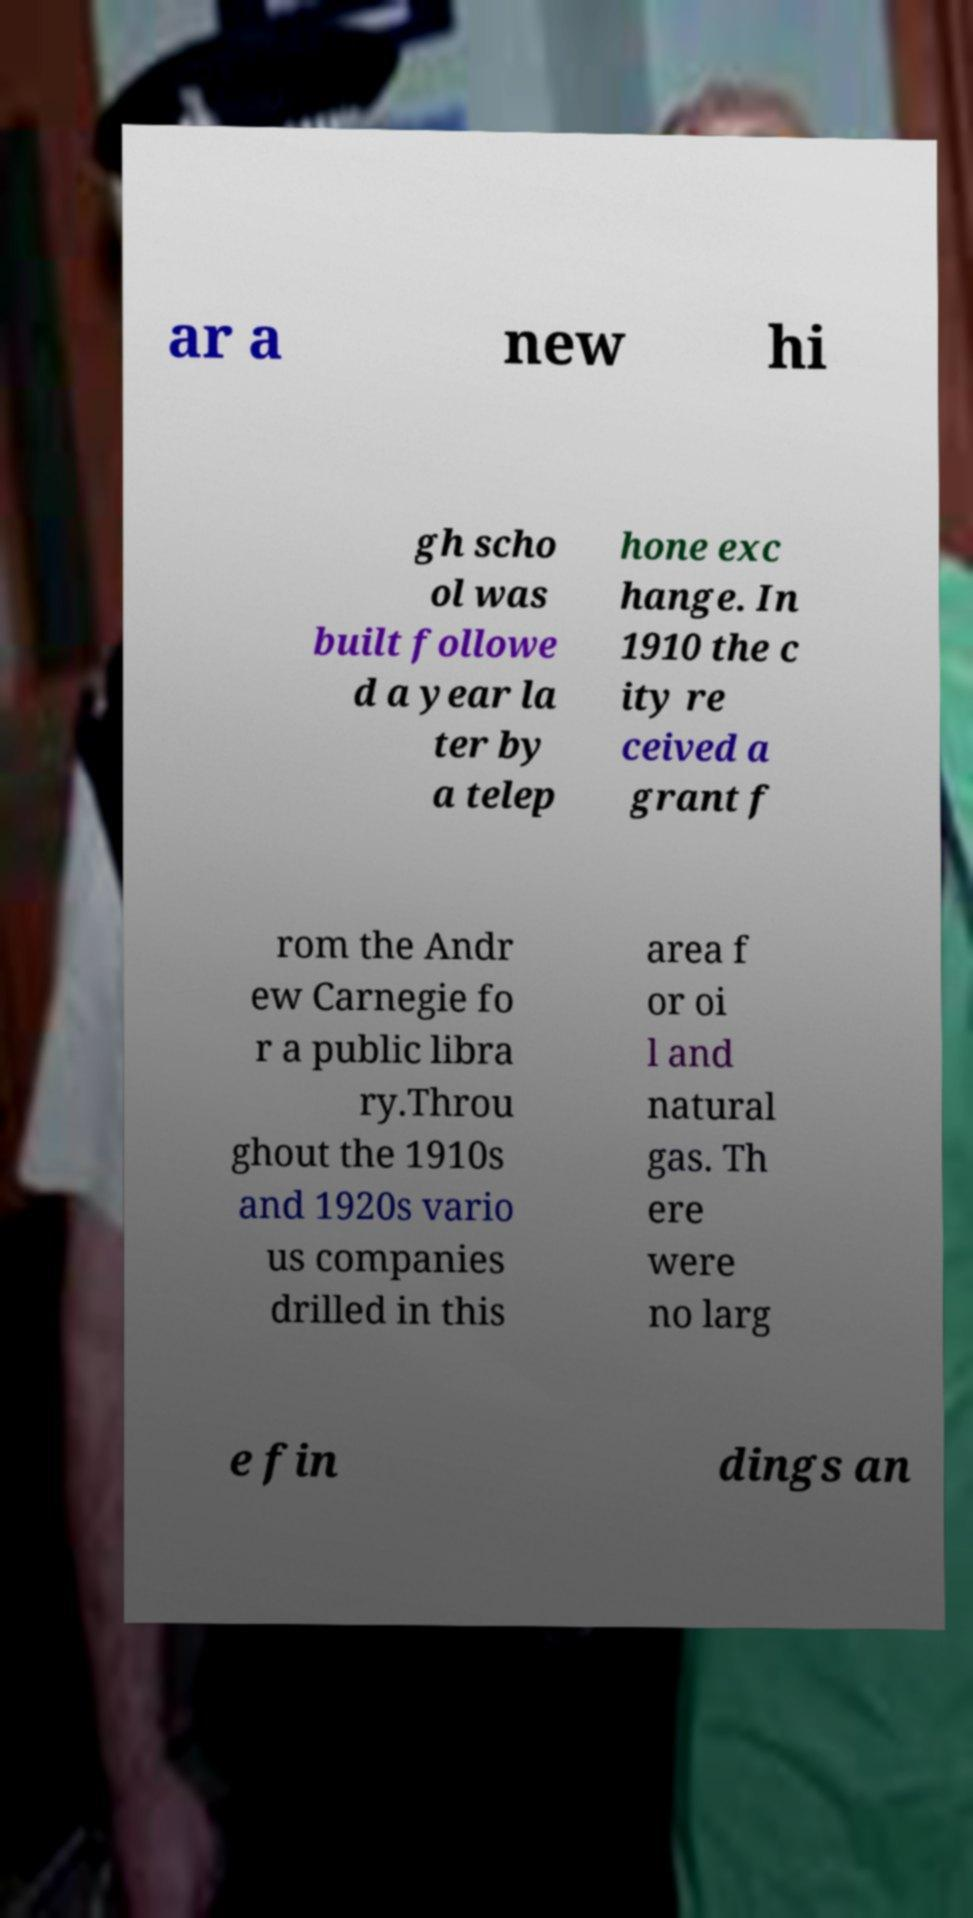Can you accurately transcribe the text from the provided image for me? ar a new hi gh scho ol was built followe d a year la ter by a telep hone exc hange. In 1910 the c ity re ceived a grant f rom the Andr ew Carnegie fo r a public libra ry.Throu ghout the 1910s and 1920s vario us companies drilled in this area f or oi l and natural gas. Th ere were no larg e fin dings an 